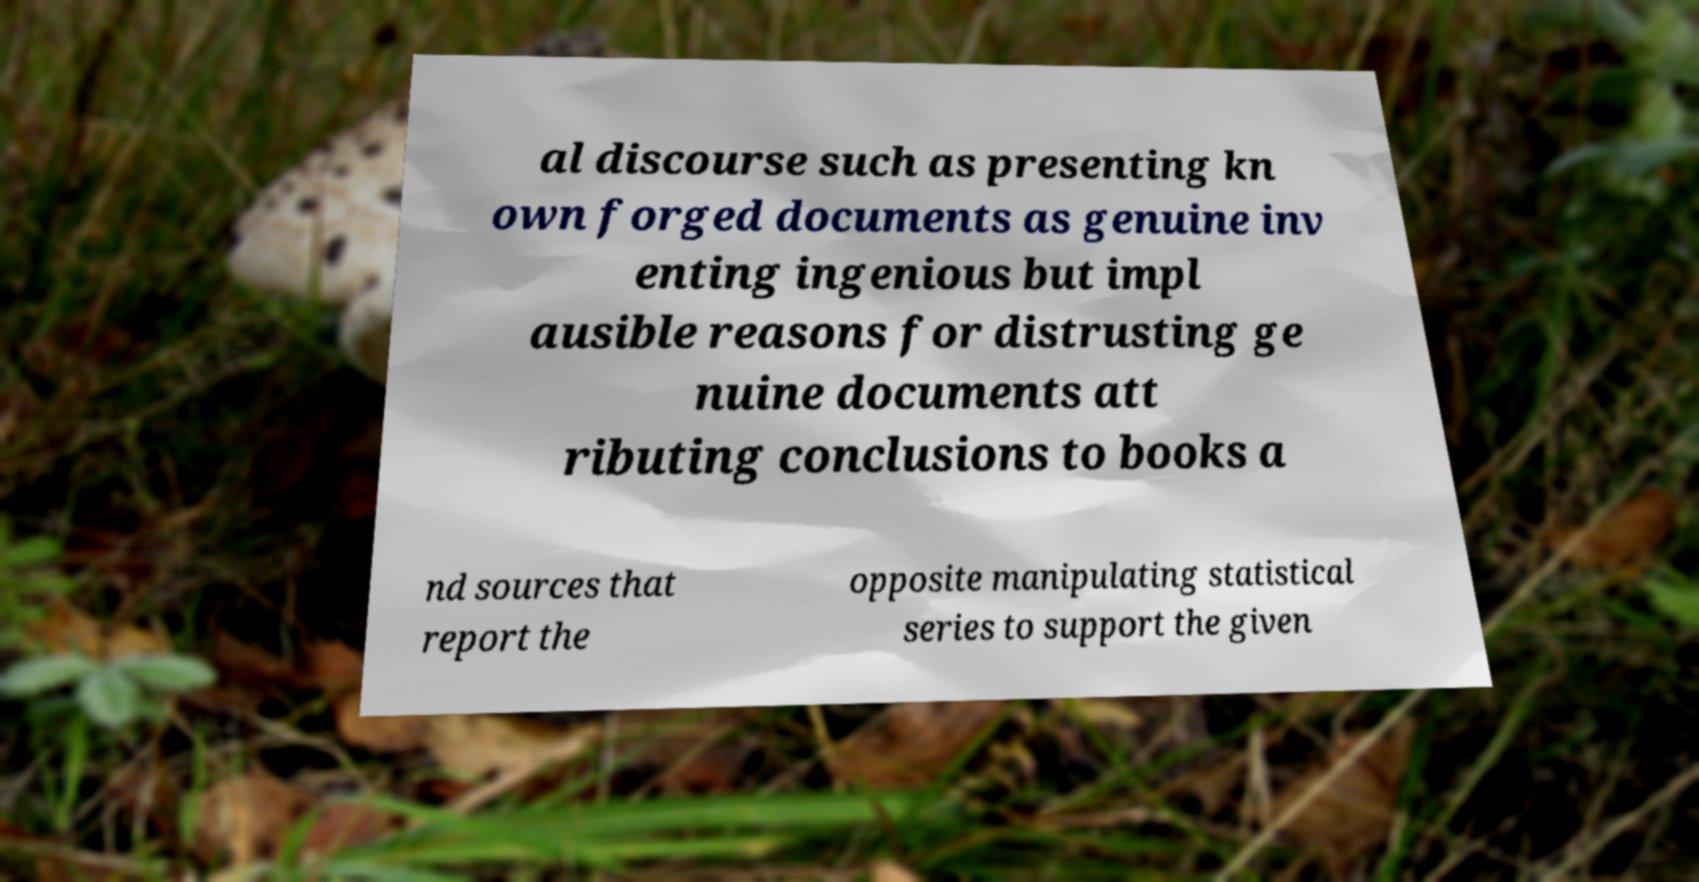For documentation purposes, I need the text within this image transcribed. Could you provide that? al discourse such as presenting kn own forged documents as genuine inv enting ingenious but impl ausible reasons for distrusting ge nuine documents att ributing conclusions to books a nd sources that report the opposite manipulating statistical series to support the given 